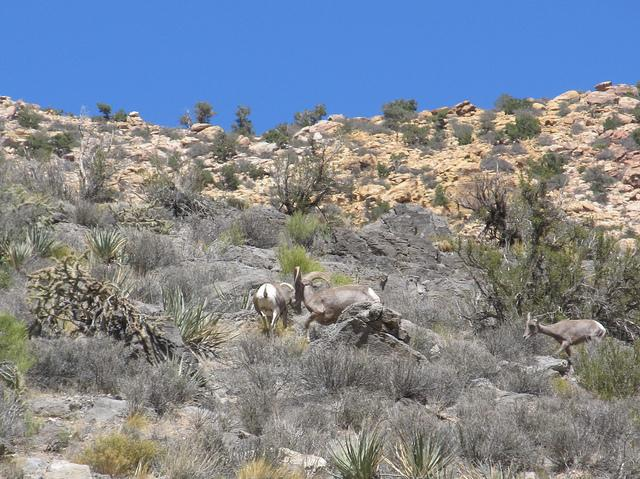What does the sky depict about the weather?

Choices:
A) clear
B) cloudy
C) rainy
D) foggy clear 